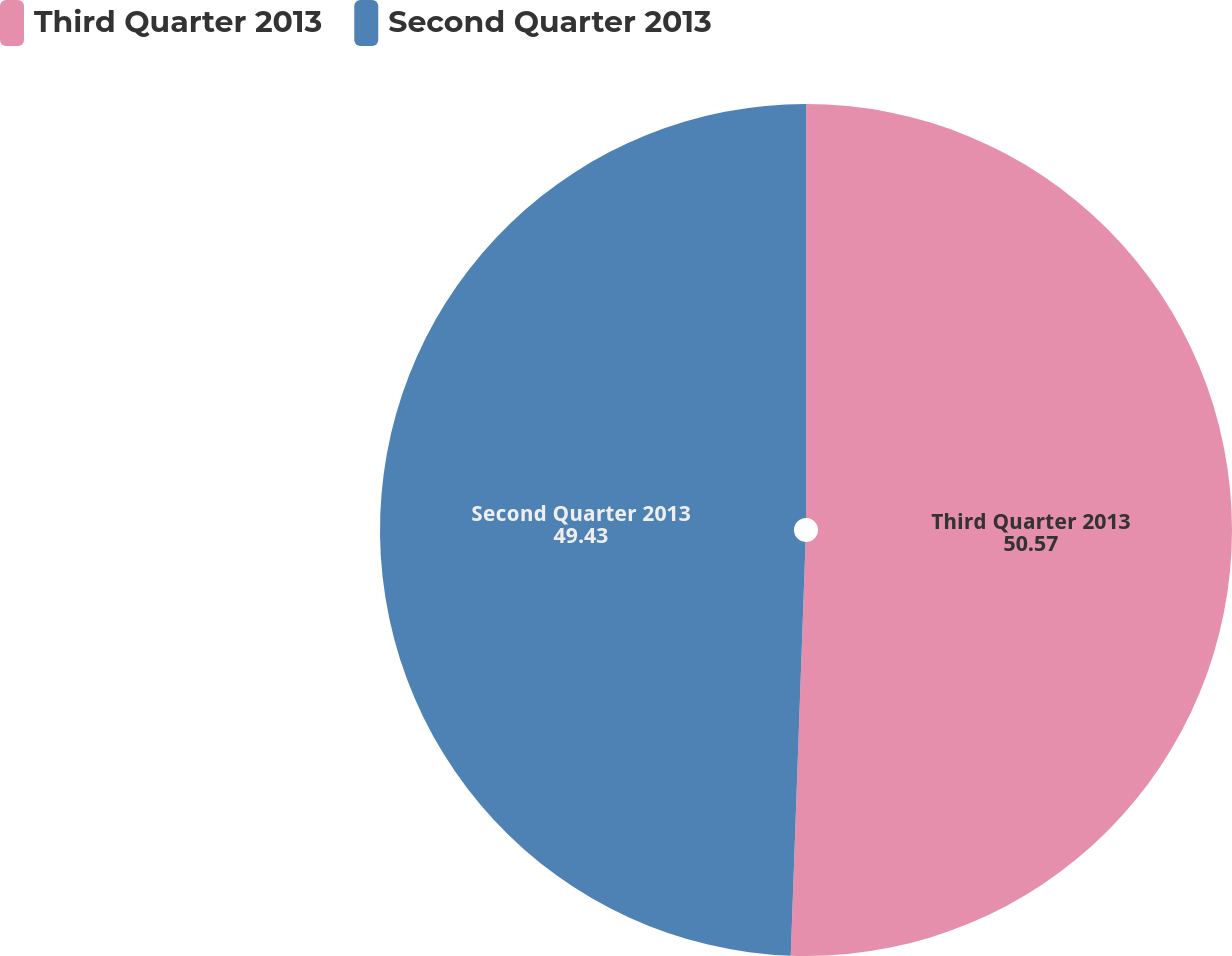Convert chart to OTSL. <chart><loc_0><loc_0><loc_500><loc_500><pie_chart><fcel>Third Quarter 2013<fcel>Second Quarter 2013<nl><fcel>50.57%<fcel>49.43%<nl></chart> 